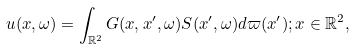<formula> <loc_0><loc_0><loc_500><loc_500>u ( x , \omega ) = \int _ { \mathbb { R } ^ { 2 } } G ( x , x ^ { \prime } , \omega ) S ( x ^ { \prime } , \omega ) d \varpi ( x ^ { \prime } ) ; x \in \mathbb { R } ^ { 2 } ,</formula> 